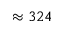Convert formula to latex. <formula><loc_0><loc_0><loc_500><loc_500>\approx 3 2 4</formula> 